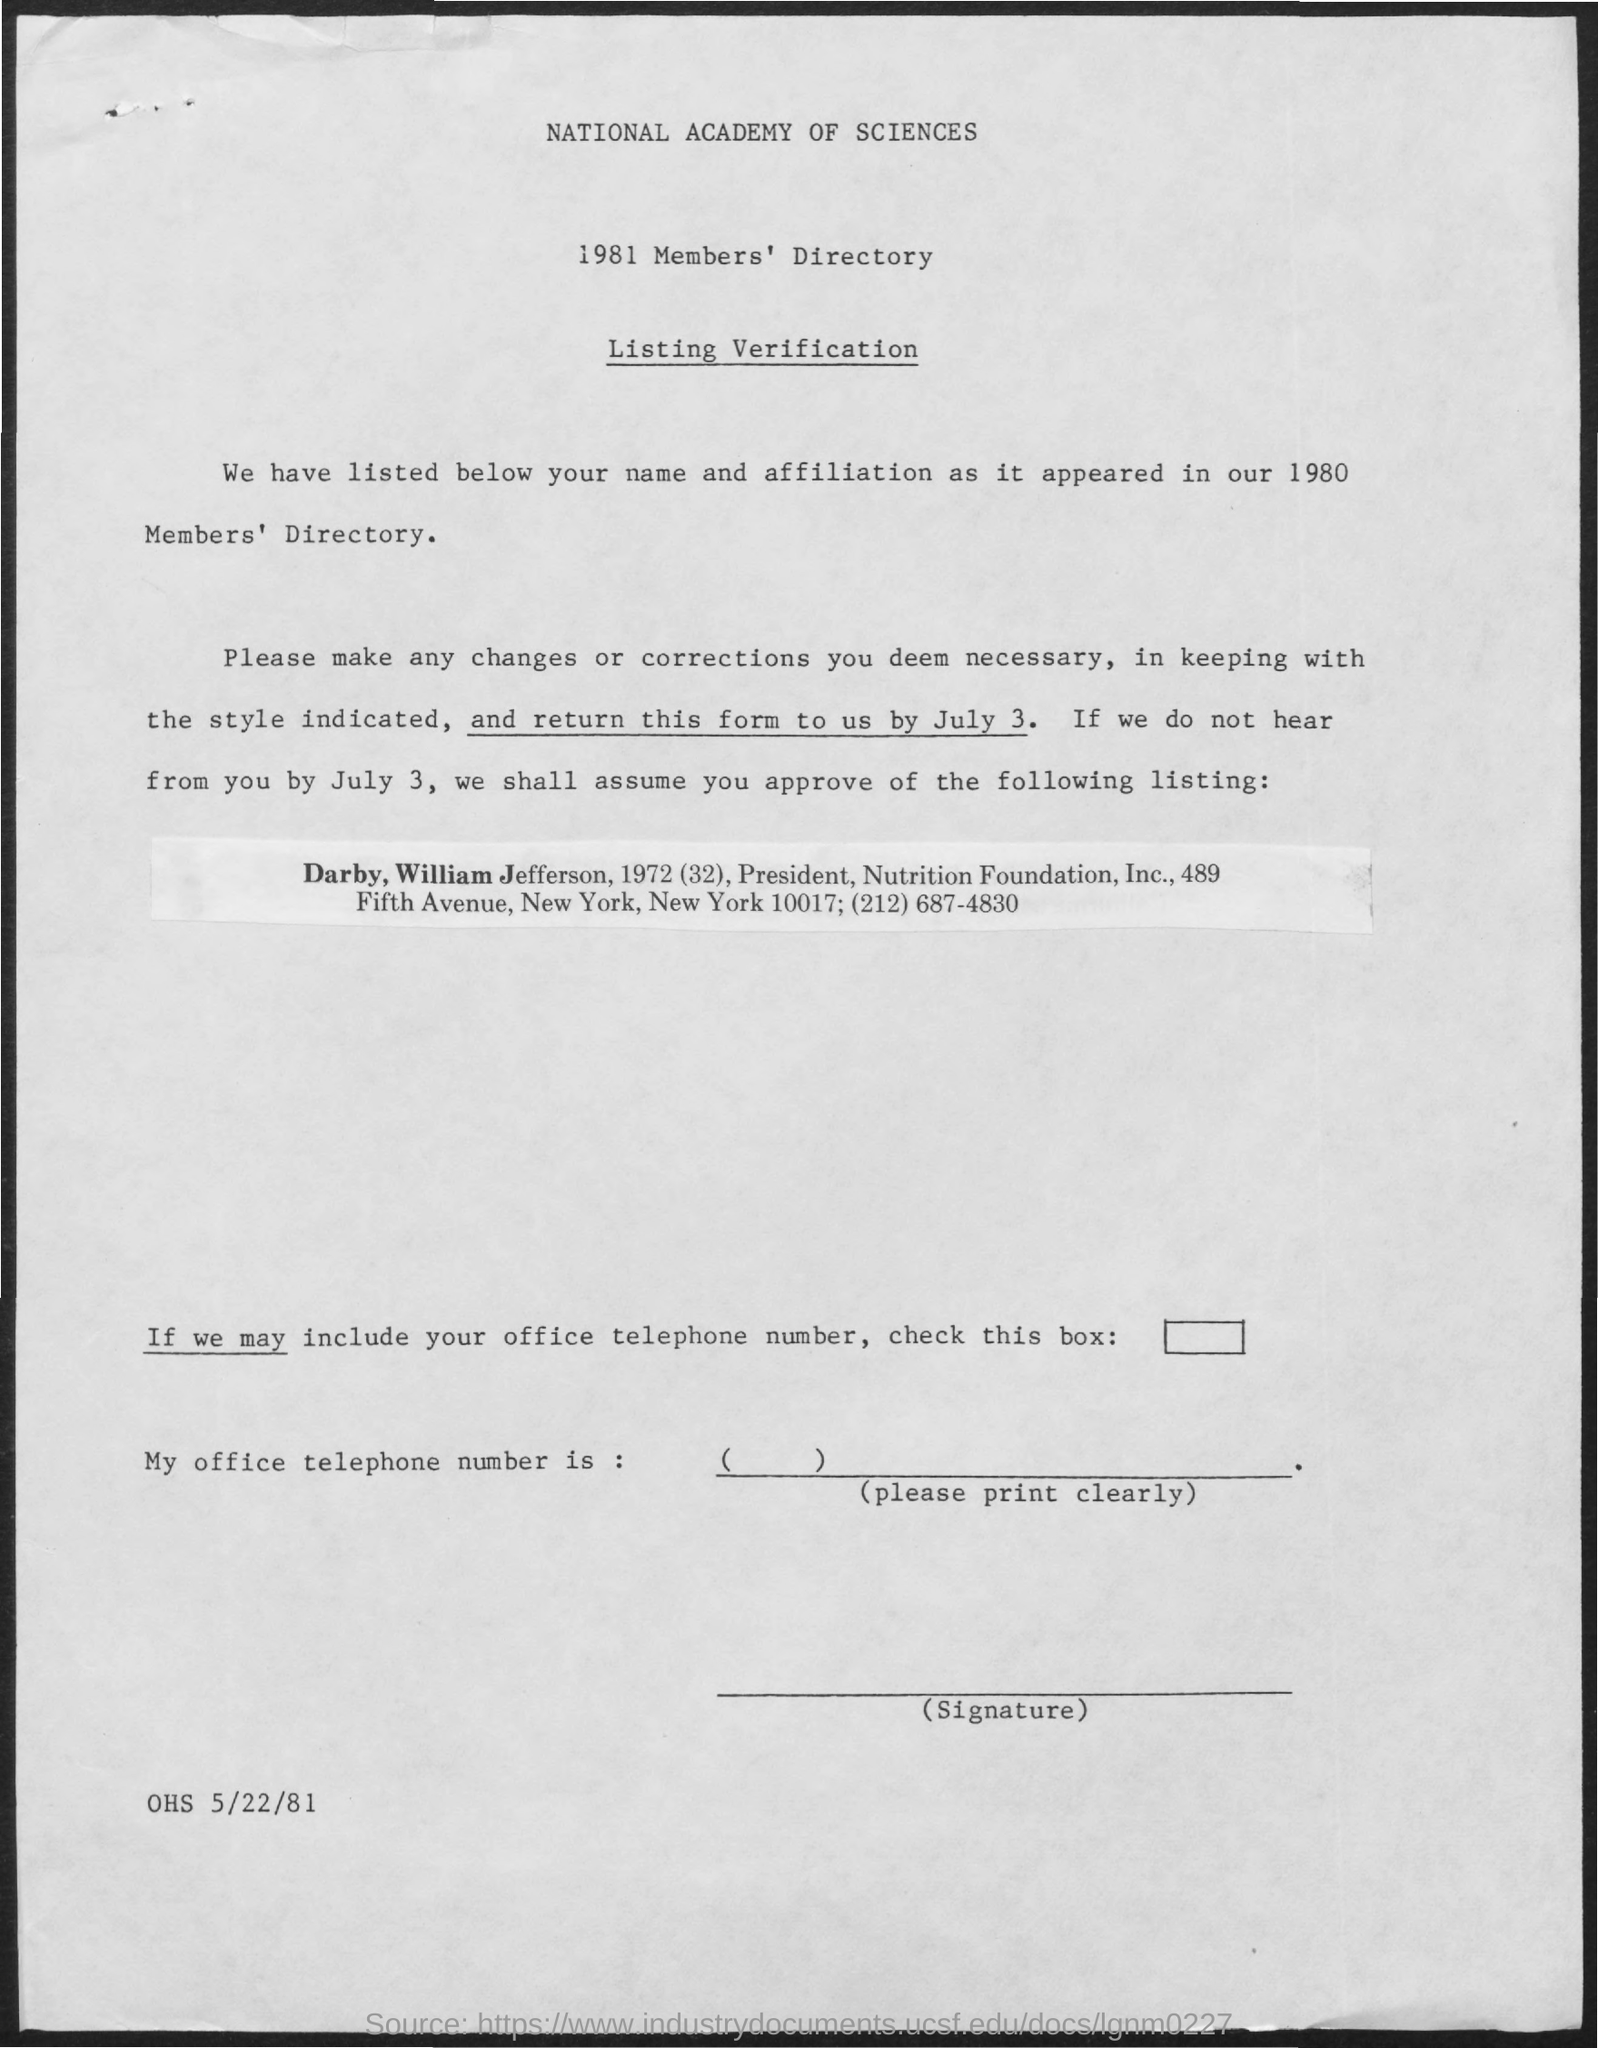Give some essential details in this illustration. The second title in the document is 1981 Members' Directory. The first title in the document is 'National Academy of Sciences.' The third title in the document is 'Listing Verification'. 